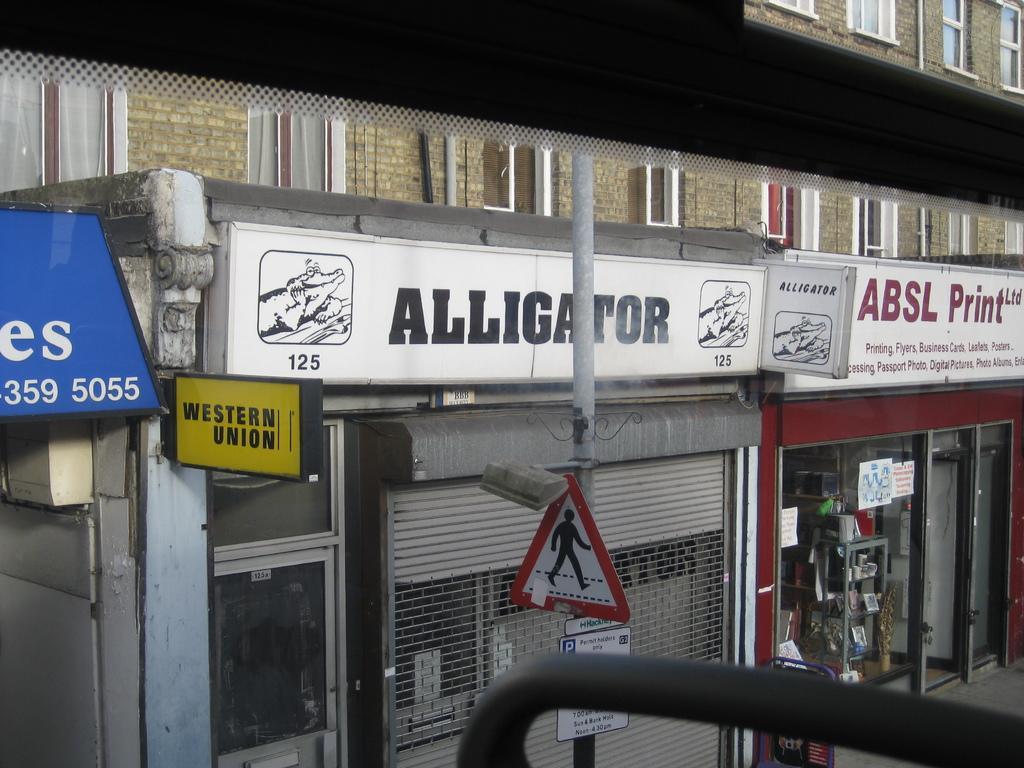Please provide a concise description of this image. In this image we can see buildings, there are windows, a pole, signboard, there are boards with text on it, there are some objects on the racks, there is a shutter, there are posters on the glass door. 